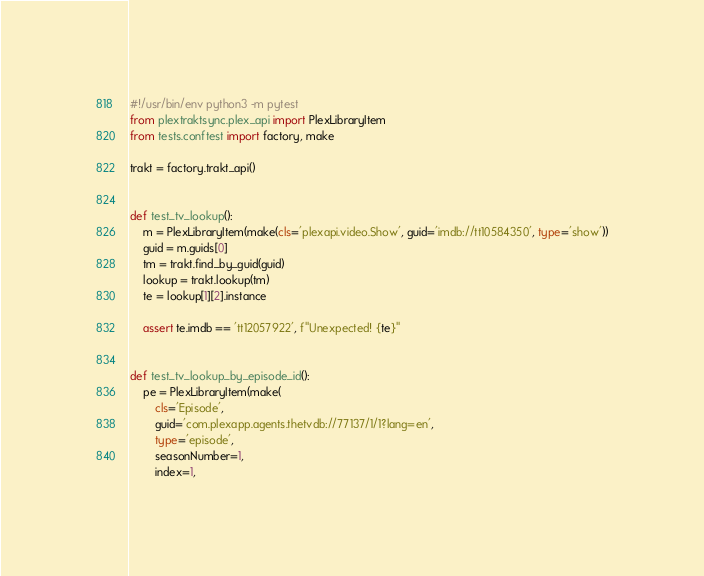Convert code to text. <code><loc_0><loc_0><loc_500><loc_500><_Python_>#!/usr/bin/env python3 -m pytest
from plextraktsync.plex_api import PlexLibraryItem
from tests.conftest import factory, make

trakt = factory.trakt_api()


def test_tv_lookup():
    m = PlexLibraryItem(make(cls='plexapi.video.Show', guid='imdb://tt10584350', type='show'))
    guid = m.guids[0]
    tm = trakt.find_by_guid(guid)
    lookup = trakt.lookup(tm)
    te = lookup[1][2].instance

    assert te.imdb == 'tt12057922', f"Unexpected! {te}"


def test_tv_lookup_by_episode_id():
    pe = PlexLibraryItem(make(
        cls='Episode',
        guid='com.plexapp.agents.thetvdb://77137/1/1?lang=en',
        type='episode',
        seasonNumber=1,
        index=1,</code> 